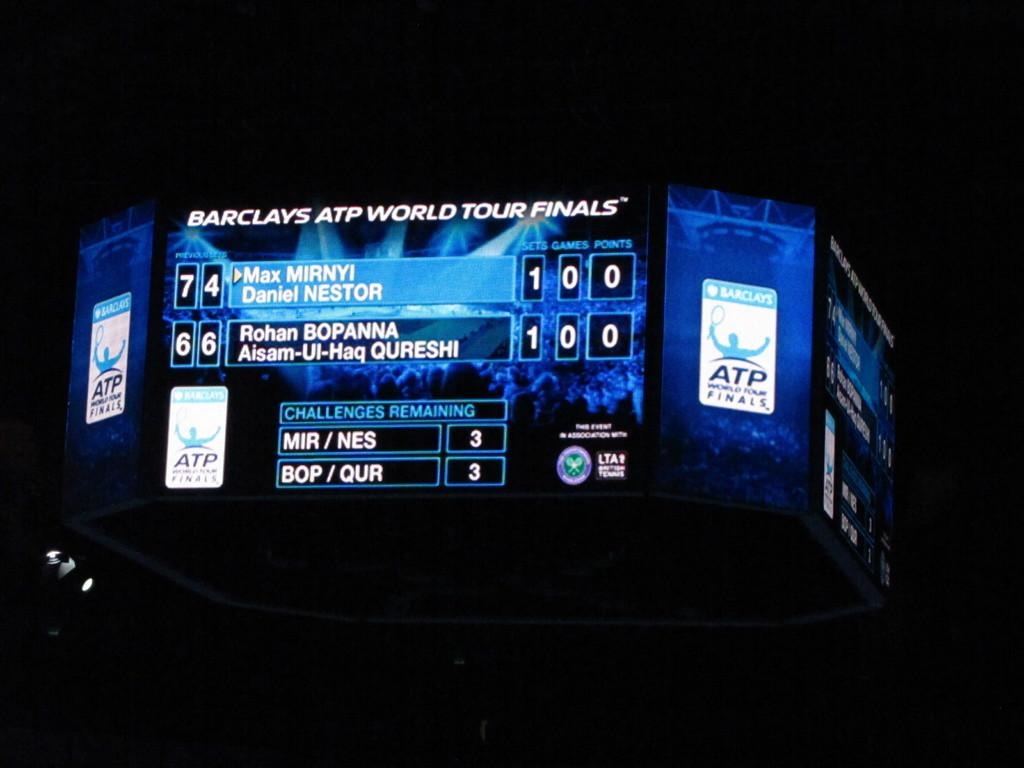<image>
Offer a succinct explanation of the picture presented. Mirnyi and Bopanna show a tied score  on the Black and blue scoreboard. 